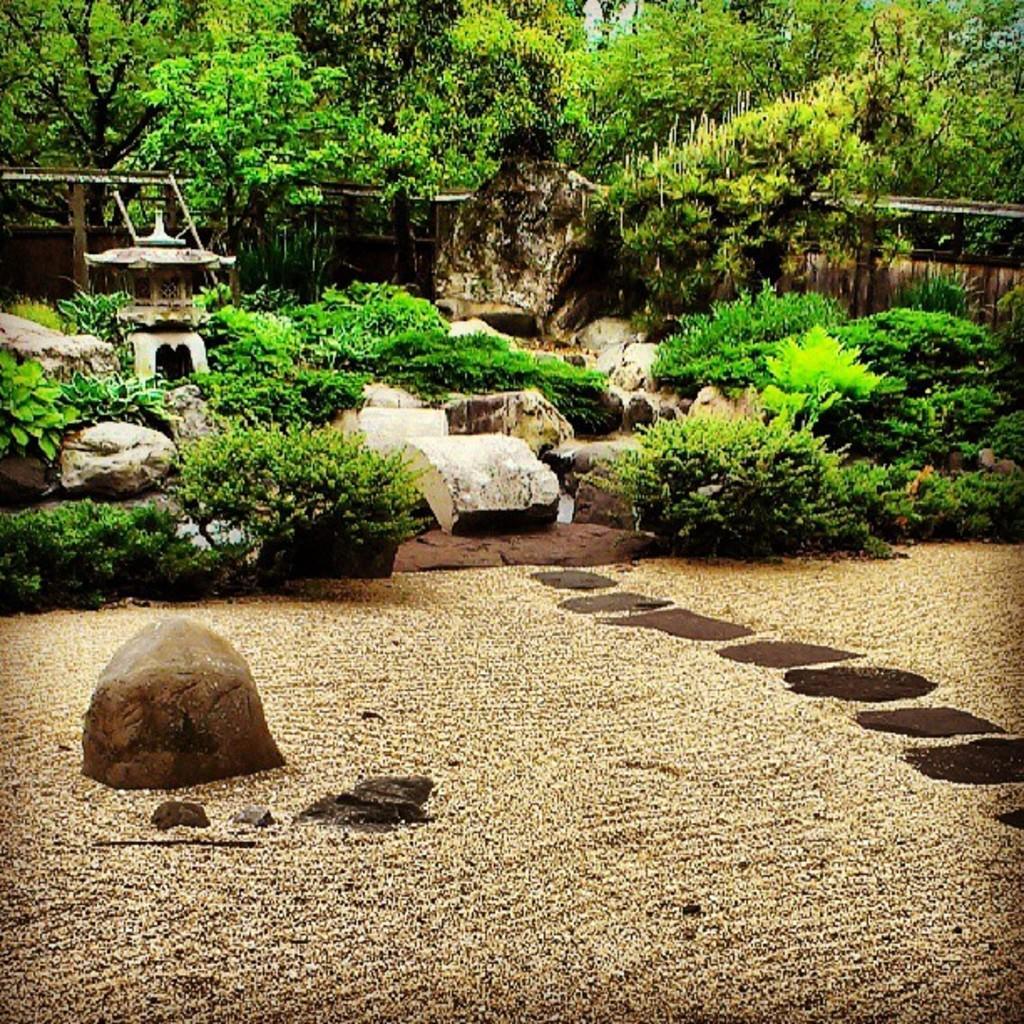How would you summarize this image in a sentence or two? In this image there are trees truncated towards the top of the image, there are plants, there are rocks, there is a rock truncated towards the left of the image, there are plants truncated towards the left of the image, there are plants truncated towards the right of the image, there is a wooden wall truncated. 